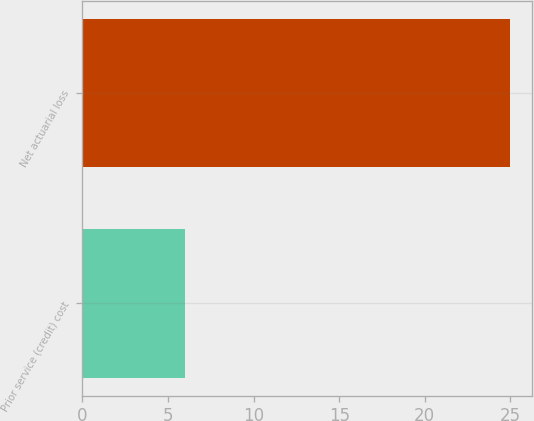<chart> <loc_0><loc_0><loc_500><loc_500><bar_chart><fcel>Prior service (credit) cost<fcel>Net actuarial loss<nl><fcel>6<fcel>25<nl></chart> 